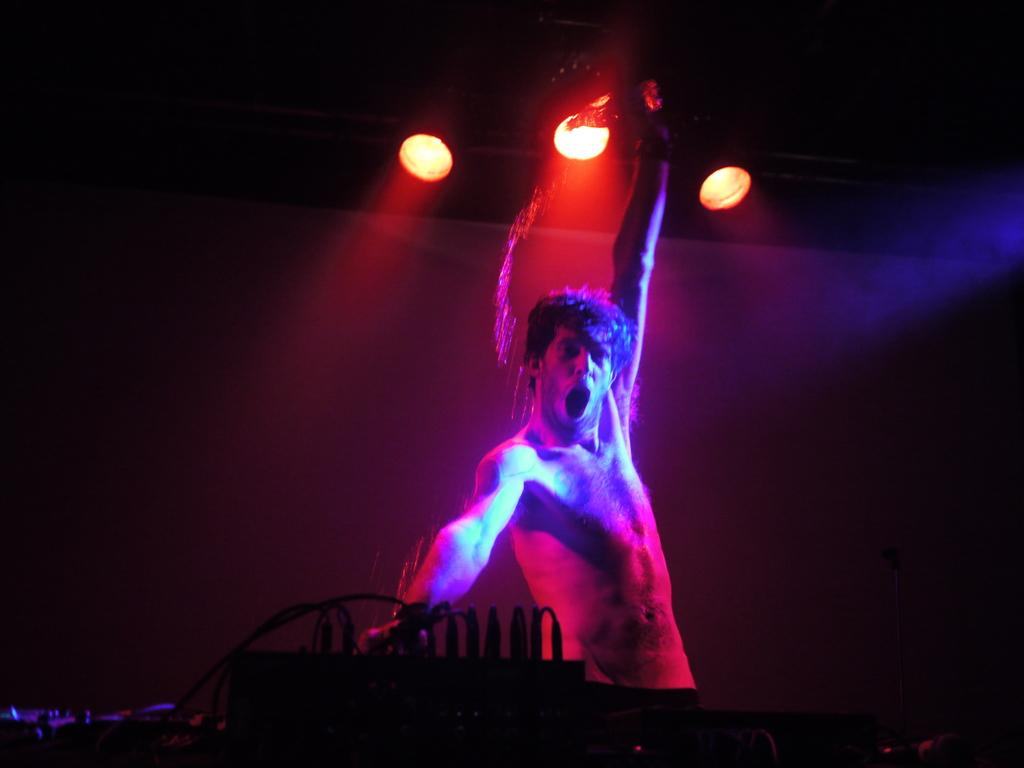Who or what is present in the image? There is a person in the image. What can be seen at the bottom of the image? There is musical equipment at the bottom of the image. What is visible at the top of the image? There are lights at the top of the image. What type of patch is being sewn onto the person's neck in the image? There is no patch or sewing activity present in the image. 